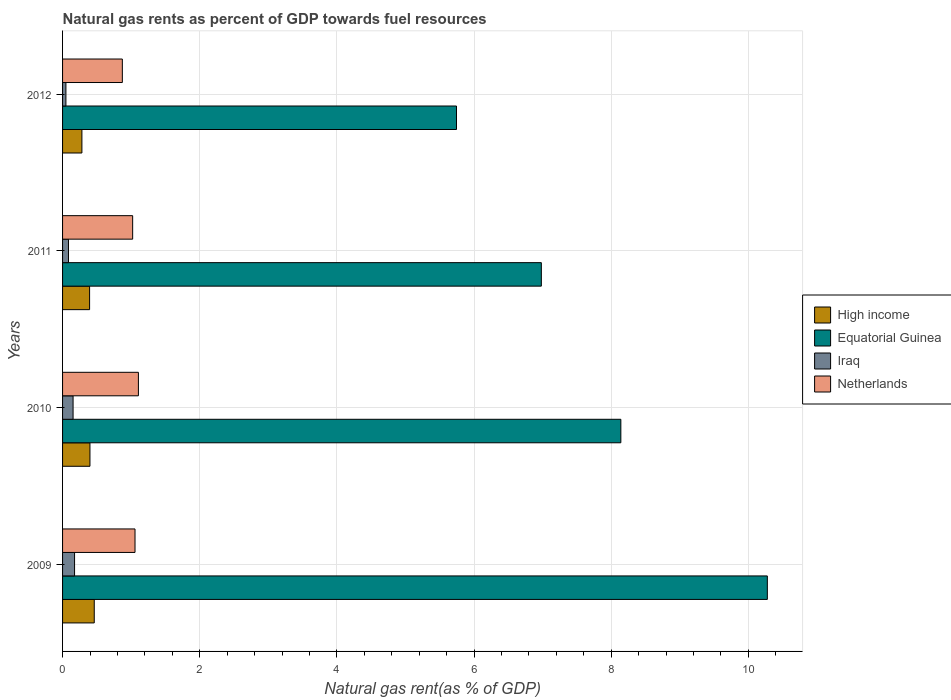How many different coloured bars are there?
Offer a terse response. 4. In how many cases, is the number of bars for a given year not equal to the number of legend labels?
Make the answer very short. 0. What is the natural gas rent in High income in 2010?
Your response must be concise. 0.4. Across all years, what is the maximum natural gas rent in Iraq?
Keep it short and to the point. 0.17. Across all years, what is the minimum natural gas rent in High income?
Offer a terse response. 0.28. In which year was the natural gas rent in Equatorial Guinea minimum?
Your answer should be compact. 2012. What is the total natural gas rent in Equatorial Guinea in the graph?
Offer a terse response. 31.14. What is the difference between the natural gas rent in High income in 2009 and that in 2010?
Your answer should be very brief. 0.06. What is the difference between the natural gas rent in Iraq in 2010 and the natural gas rent in Netherlands in 2011?
Provide a short and direct response. -0.87. What is the average natural gas rent in Equatorial Guinea per year?
Ensure brevity in your answer.  7.79. In the year 2011, what is the difference between the natural gas rent in Iraq and natural gas rent in High income?
Provide a succinct answer. -0.31. What is the ratio of the natural gas rent in Equatorial Guinea in 2009 to that in 2012?
Your answer should be compact. 1.79. Is the difference between the natural gas rent in Iraq in 2009 and 2010 greater than the difference between the natural gas rent in High income in 2009 and 2010?
Offer a very short reply. No. What is the difference between the highest and the second highest natural gas rent in Equatorial Guinea?
Your answer should be compact. 2.14. What is the difference between the highest and the lowest natural gas rent in Equatorial Guinea?
Offer a terse response. 4.53. In how many years, is the natural gas rent in Iraq greater than the average natural gas rent in Iraq taken over all years?
Provide a succinct answer. 2. Is the sum of the natural gas rent in Netherlands in 2010 and 2011 greater than the maximum natural gas rent in Iraq across all years?
Ensure brevity in your answer.  Yes. Is it the case that in every year, the sum of the natural gas rent in High income and natural gas rent in Netherlands is greater than the sum of natural gas rent in Equatorial Guinea and natural gas rent in Iraq?
Ensure brevity in your answer.  Yes. What does the 3rd bar from the top in 2009 represents?
Ensure brevity in your answer.  Equatorial Guinea. Are all the bars in the graph horizontal?
Ensure brevity in your answer.  Yes. Does the graph contain grids?
Provide a succinct answer. Yes. Where does the legend appear in the graph?
Give a very brief answer. Center right. How are the legend labels stacked?
Offer a very short reply. Vertical. What is the title of the graph?
Ensure brevity in your answer.  Natural gas rents as percent of GDP towards fuel resources. What is the label or title of the X-axis?
Keep it short and to the point. Natural gas rent(as % of GDP). What is the Natural gas rent(as % of GDP) of High income in 2009?
Your response must be concise. 0.46. What is the Natural gas rent(as % of GDP) of Equatorial Guinea in 2009?
Ensure brevity in your answer.  10.28. What is the Natural gas rent(as % of GDP) of Iraq in 2009?
Your response must be concise. 0.17. What is the Natural gas rent(as % of GDP) of Netherlands in 2009?
Keep it short and to the point. 1.06. What is the Natural gas rent(as % of GDP) of High income in 2010?
Your answer should be very brief. 0.4. What is the Natural gas rent(as % of GDP) of Equatorial Guinea in 2010?
Give a very brief answer. 8.14. What is the Natural gas rent(as % of GDP) in Iraq in 2010?
Give a very brief answer. 0.15. What is the Natural gas rent(as % of GDP) in Netherlands in 2010?
Ensure brevity in your answer.  1.11. What is the Natural gas rent(as % of GDP) in High income in 2011?
Ensure brevity in your answer.  0.39. What is the Natural gas rent(as % of GDP) of Equatorial Guinea in 2011?
Your answer should be very brief. 6.98. What is the Natural gas rent(as % of GDP) in Iraq in 2011?
Offer a very short reply. 0.09. What is the Natural gas rent(as % of GDP) in Netherlands in 2011?
Make the answer very short. 1.02. What is the Natural gas rent(as % of GDP) in High income in 2012?
Your response must be concise. 0.28. What is the Natural gas rent(as % of GDP) in Equatorial Guinea in 2012?
Your response must be concise. 5.74. What is the Natural gas rent(as % of GDP) of Iraq in 2012?
Offer a very short reply. 0.05. What is the Natural gas rent(as % of GDP) in Netherlands in 2012?
Make the answer very short. 0.87. Across all years, what is the maximum Natural gas rent(as % of GDP) of High income?
Make the answer very short. 0.46. Across all years, what is the maximum Natural gas rent(as % of GDP) of Equatorial Guinea?
Provide a short and direct response. 10.28. Across all years, what is the maximum Natural gas rent(as % of GDP) in Iraq?
Your response must be concise. 0.17. Across all years, what is the maximum Natural gas rent(as % of GDP) of Netherlands?
Your answer should be very brief. 1.11. Across all years, what is the minimum Natural gas rent(as % of GDP) of High income?
Offer a very short reply. 0.28. Across all years, what is the minimum Natural gas rent(as % of GDP) of Equatorial Guinea?
Ensure brevity in your answer.  5.74. Across all years, what is the minimum Natural gas rent(as % of GDP) of Iraq?
Your response must be concise. 0.05. Across all years, what is the minimum Natural gas rent(as % of GDP) of Netherlands?
Give a very brief answer. 0.87. What is the total Natural gas rent(as % of GDP) of High income in the graph?
Ensure brevity in your answer.  1.54. What is the total Natural gas rent(as % of GDP) in Equatorial Guinea in the graph?
Ensure brevity in your answer.  31.14. What is the total Natural gas rent(as % of GDP) of Iraq in the graph?
Ensure brevity in your answer.  0.46. What is the total Natural gas rent(as % of GDP) in Netherlands in the graph?
Offer a very short reply. 4.06. What is the difference between the Natural gas rent(as % of GDP) of High income in 2009 and that in 2010?
Offer a terse response. 0.06. What is the difference between the Natural gas rent(as % of GDP) in Equatorial Guinea in 2009 and that in 2010?
Your answer should be compact. 2.14. What is the difference between the Natural gas rent(as % of GDP) of Iraq in 2009 and that in 2010?
Give a very brief answer. 0.02. What is the difference between the Natural gas rent(as % of GDP) of Netherlands in 2009 and that in 2010?
Your answer should be compact. -0.05. What is the difference between the Natural gas rent(as % of GDP) in High income in 2009 and that in 2011?
Ensure brevity in your answer.  0.07. What is the difference between the Natural gas rent(as % of GDP) of Equatorial Guinea in 2009 and that in 2011?
Your answer should be compact. 3.3. What is the difference between the Natural gas rent(as % of GDP) in Iraq in 2009 and that in 2011?
Give a very brief answer. 0.09. What is the difference between the Natural gas rent(as % of GDP) of Netherlands in 2009 and that in 2011?
Give a very brief answer. 0.03. What is the difference between the Natural gas rent(as % of GDP) of High income in 2009 and that in 2012?
Provide a short and direct response. 0.18. What is the difference between the Natural gas rent(as % of GDP) in Equatorial Guinea in 2009 and that in 2012?
Keep it short and to the point. 4.53. What is the difference between the Natural gas rent(as % of GDP) of Iraq in 2009 and that in 2012?
Offer a terse response. 0.13. What is the difference between the Natural gas rent(as % of GDP) of Netherlands in 2009 and that in 2012?
Offer a very short reply. 0.18. What is the difference between the Natural gas rent(as % of GDP) in High income in 2010 and that in 2011?
Your answer should be compact. 0.01. What is the difference between the Natural gas rent(as % of GDP) of Equatorial Guinea in 2010 and that in 2011?
Make the answer very short. 1.16. What is the difference between the Natural gas rent(as % of GDP) in Iraq in 2010 and that in 2011?
Your answer should be very brief. 0.07. What is the difference between the Natural gas rent(as % of GDP) in Netherlands in 2010 and that in 2011?
Your answer should be compact. 0.08. What is the difference between the Natural gas rent(as % of GDP) in High income in 2010 and that in 2012?
Your answer should be compact. 0.12. What is the difference between the Natural gas rent(as % of GDP) of Equatorial Guinea in 2010 and that in 2012?
Provide a short and direct response. 2.4. What is the difference between the Natural gas rent(as % of GDP) of Iraq in 2010 and that in 2012?
Provide a succinct answer. 0.1. What is the difference between the Natural gas rent(as % of GDP) in Netherlands in 2010 and that in 2012?
Provide a succinct answer. 0.23. What is the difference between the Natural gas rent(as % of GDP) of High income in 2011 and that in 2012?
Provide a succinct answer. 0.11. What is the difference between the Natural gas rent(as % of GDP) in Equatorial Guinea in 2011 and that in 2012?
Give a very brief answer. 1.24. What is the difference between the Natural gas rent(as % of GDP) of Iraq in 2011 and that in 2012?
Your answer should be very brief. 0.04. What is the difference between the Natural gas rent(as % of GDP) in Netherlands in 2011 and that in 2012?
Provide a short and direct response. 0.15. What is the difference between the Natural gas rent(as % of GDP) in High income in 2009 and the Natural gas rent(as % of GDP) in Equatorial Guinea in 2010?
Your answer should be compact. -7.68. What is the difference between the Natural gas rent(as % of GDP) of High income in 2009 and the Natural gas rent(as % of GDP) of Iraq in 2010?
Make the answer very short. 0.31. What is the difference between the Natural gas rent(as % of GDP) in High income in 2009 and the Natural gas rent(as % of GDP) in Netherlands in 2010?
Offer a terse response. -0.64. What is the difference between the Natural gas rent(as % of GDP) in Equatorial Guinea in 2009 and the Natural gas rent(as % of GDP) in Iraq in 2010?
Offer a terse response. 10.12. What is the difference between the Natural gas rent(as % of GDP) in Equatorial Guinea in 2009 and the Natural gas rent(as % of GDP) in Netherlands in 2010?
Provide a succinct answer. 9.17. What is the difference between the Natural gas rent(as % of GDP) of Iraq in 2009 and the Natural gas rent(as % of GDP) of Netherlands in 2010?
Provide a succinct answer. -0.93. What is the difference between the Natural gas rent(as % of GDP) in High income in 2009 and the Natural gas rent(as % of GDP) in Equatorial Guinea in 2011?
Provide a succinct answer. -6.52. What is the difference between the Natural gas rent(as % of GDP) in High income in 2009 and the Natural gas rent(as % of GDP) in Iraq in 2011?
Your response must be concise. 0.38. What is the difference between the Natural gas rent(as % of GDP) of High income in 2009 and the Natural gas rent(as % of GDP) of Netherlands in 2011?
Your answer should be very brief. -0.56. What is the difference between the Natural gas rent(as % of GDP) of Equatorial Guinea in 2009 and the Natural gas rent(as % of GDP) of Iraq in 2011?
Provide a succinct answer. 10.19. What is the difference between the Natural gas rent(as % of GDP) of Equatorial Guinea in 2009 and the Natural gas rent(as % of GDP) of Netherlands in 2011?
Ensure brevity in your answer.  9.25. What is the difference between the Natural gas rent(as % of GDP) in Iraq in 2009 and the Natural gas rent(as % of GDP) in Netherlands in 2011?
Make the answer very short. -0.85. What is the difference between the Natural gas rent(as % of GDP) of High income in 2009 and the Natural gas rent(as % of GDP) of Equatorial Guinea in 2012?
Make the answer very short. -5.28. What is the difference between the Natural gas rent(as % of GDP) in High income in 2009 and the Natural gas rent(as % of GDP) in Iraq in 2012?
Ensure brevity in your answer.  0.41. What is the difference between the Natural gas rent(as % of GDP) in High income in 2009 and the Natural gas rent(as % of GDP) in Netherlands in 2012?
Keep it short and to the point. -0.41. What is the difference between the Natural gas rent(as % of GDP) of Equatorial Guinea in 2009 and the Natural gas rent(as % of GDP) of Iraq in 2012?
Keep it short and to the point. 10.23. What is the difference between the Natural gas rent(as % of GDP) of Equatorial Guinea in 2009 and the Natural gas rent(as % of GDP) of Netherlands in 2012?
Offer a terse response. 9.41. What is the difference between the Natural gas rent(as % of GDP) in Iraq in 2009 and the Natural gas rent(as % of GDP) in Netherlands in 2012?
Keep it short and to the point. -0.7. What is the difference between the Natural gas rent(as % of GDP) of High income in 2010 and the Natural gas rent(as % of GDP) of Equatorial Guinea in 2011?
Keep it short and to the point. -6.58. What is the difference between the Natural gas rent(as % of GDP) of High income in 2010 and the Natural gas rent(as % of GDP) of Iraq in 2011?
Provide a succinct answer. 0.31. What is the difference between the Natural gas rent(as % of GDP) in High income in 2010 and the Natural gas rent(as % of GDP) in Netherlands in 2011?
Your answer should be very brief. -0.62. What is the difference between the Natural gas rent(as % of GDP) in Equatorial Guinea in 2010 and the Natural gas rent(as % of GDP) in Iraq in 2011?
Ensure brevity in your answer.  8.05. What is the difference between the Natural gas rent(as % of GDP) of Equatorial Guinea in 2010 and the Natural gas rent(as % of GDP) of Netherlands in 2011?
Ensure brevity in your answer.  7.12. What is the difference between the Natural gas rent(as % of GDP) of Iraq in 2010 and the Natural gas rent(as % of GDP) of Netherlands in 2011?
Your answer should be compact. -0.87. What is the difference between the Natural gas rent(as % of GDP) in High income in 2010 and the Natural gas rent(as % of GDP) in Equatorial Guinea in 2012?
Keep it short and to the point. -5.34. What is the difference between the Natural gas rent(as % of GDP) in High income in 2010 and the Natural gas rent(as % of GDP) in Iraq in 2012?
Provide a succinct answer. 0.35. What is the difference between the Natural gas rent(as % of GDP) in High income in 2010 and the Natural gas rent(as % of GDP) in Netherlands in 2012?
Your response must be concise. -0.47. What is the difference between the Natural gas rent(as % of GDP) in Equatorial Guinea in 2010 and the Natural gas rent(as % of GDP) in Iraq in 2012?
Your answer should be very brief. 8.09. What is the difference between the Natural gas rent(as % of GDP) in Equatorial Guinea in 2010 and the Natural gas rent(as % of GDP) in Netherlands in 2012?
Keep it short and to the point. 7.27. What is the difference between the Natural gas rent(as % of GDP) of Iraq in 2010 and the Natural gas rent(as % of GDP) of Netherlands in 2012?
Your answer should be compact. -0.72. What is the difference between the Natural gas rent(as % of GDP) of High income in 2011 and the Natural gas rent(as % of GDP) of Equatorial Guinea in 2012?
Give a very brief answer. -5.35. What is the difference between the Natural gas rent(as % of GDP) of High income in 2011 and the Natural gas rent(as % of GDP) of Iraq in 2012?
Ensure brevity in your answer.  0.35. What is the difference between the Natural gas rent(as % of GDP) of High income in 2011 and the Natural gas rent(as % of GDP) of Netherlands in 2012?
Your response must be concise. -0.48. What is the difference between the Natural gas rent(as % of GDP) in Equatorial Guinea in 2011 and the Natural gas rent(as % of GDP) in Iraq in 2012?
Offer a terse response. 6.93. What is the difference between the Natural gas rent(as % of GDP) in Equatorial Guinea in 2011 and the Natural gas rent(as % of GDP) in Netherlands in 2012?
Provide a succinct answer. 6.11. What is the difference between the Natural gas rent(as % of GDP) of Iraq in 2011 and the Natural gas rent(as % of GDP) of Netherlands in 2012?
Make the answer very short. -0.79. What is the average Natural gas rent(as % of GDP) of High income per year?
Your response must be concise. 0.38. What is the average Natural gas rent(as % of GDP) of Equatorial Guinea per year?
Keep it short and to the point. 7.79. What is the average Natural gas rent(as % of GDP) of Iraq per year?
Your response must be concise. 0.12. What is the average Natural gas rent(as % of GDP) of Netherlands per year?
Keep it short and to the point. 1.01. In the year 2009, what is the difference between the Natural gas rent(as % of GDP) in High income and Natural gas rent(as % of GDP) in Equatorial Guinea?
Offer a very short reply. -9.81. In the year 2009, what is the difference between the Natural gas rent(as % of GDP) in High income and Natural gas rent(as % of GDP) in Iraq?
Your answer should be very brief. 0.29. In the year 2009, what is the difference between the Natural gas rent(as % of GDP) in High income and Natural gas rent(as % of GDP) in Netherlands?
Ensure brevity in your answer.  -0.59. In the year 2009, what is the difference between the Natural gas rent(as % of GDP) of Equatorial Guinea and Natural gas rent(as % of GDP) of Iraq?
Make the answer very short. 10.1. In the year 2009, what is the difference between the Natural gas rent(as % of GDP) in Equatorial Guinea and Natural gas rent(as % of GDP) in Netherlands?
Offer a terse response. 9.22. In the year 2009, what is the difference between the Natural gas rent(as % of GDP) of Iraq and Natural gas rent(as % of GDP) of Netherlands?
Your answer should be compact. -0.88. In the year 2010, what is the difference between the Natural gas rent(as % of GDP) of High income and Natural gas rent(as % of GDP) of Equatorial Guinea?
Keep it short and to the point. -7.74. In the year 2010, what is the difference between the Natural gas rent(as % of GDP) in High income and Natural gas rent(as % of GDP) in Iraq?
Provide a succinct answer. 0.25. In the year 2010, what is the difference between the Natural gas rent(as % of GDP) of High income and Natural gas rent(as % of GDP) of Netherlands?
Your answer should be compact. -0.71. In the year 2010, what is the difference between the Natural gas rent(as % of GDP) of Equatorial Guinea and Natural gas rent(as % of GDP) of Iraq?
Offer a terse response. 7.99. In the year 2010, what is the difference between the Natural gas rent(as % of GDP) of Equatorial Guinea and Natural gas rent(as % of GDP) of Netherlands?
Offer a very short reply. 7.03. In the year 2010, what is the difference between the Natural gas rent(as % of GDP) in Iraq and Natural gas rent(as % of GDP) in Netherlands?
Offer a terse response. -0.95. In the year 2011, what is the difference between the Natural gas rent(as % of GDP) of High income and Natural gas rent(as % of GDP) of Equatorial Guinea?
Offer a terse response. -6.59. In the year 2011, what is the difference between the Natural gas rent(as % of GDP) of High income and Natural gas rent(as % of GDP) of Iraq?
Make the answer very short. 0.31. In the year 2011, what is the difference between the Natural gas rent(as % of GDP) of High income and Natural gas rent(as % of GDP) of Netherlands?
Your response must be concise. -0.63. In the year 2011, what is the difference between the Natural gas rent(as % of GDP) of Equatorial Guinea and Natural gas rent(as % of GDP) of Iraq?
Keep it short and to the point. 6.9. In the year 2011, what is the difference between the Natural gas rent(as % of GDP) of Equatorial Guinea and Natural gas rent(as % of GDP) of Netherlands?
Ensure brevity in your answer.  5.96. In the year 2011, what is the difference between the Natural gas rent(as % of GDP) of Iraq and Natural gas rent(as % of GDP) of Netherlands?
Keep it short and to the point. -0.94. In the year 2012, what is the difference between the Natural gas rent(as % of GDP) in High income and Natural gas rent(as % of GDP) in Equatorial Guinea?
Your response must be concise. -5.46. In the year 2012, what is the difference between the Natural gas rent(as % of GDP) of High income and Natural gas rent(as % of GDP) of Iraq?
Provide a succinct answer. 0.23. In the year 2012, what is the difference between the Natural gas rent(as % of GDP) in High income and Natural gas rent(as % of GDP) in Netherlands?
Give a very brief answer. -0.59. In the year 2012, what is the difference between the Natural gas rent(as % of GDP) of Equatorial Guinea and Natural gas rent(as % of GDP) of Iraq?
Offer a very short reply. 5.7. In the year 2012, what is the difference between the Natural gas rent(as % of GDP) of Equatorial Guinea and Natural gas rent(as % of GDP) of Netherlands?
Ensure brevity in your answer.  4.87. In the year 2012, what is the difference between the Natural gas rent(as % of GDP) in Iraq and Natural gas rent(as % of GDP) in Netherlands?
Provide a succinct answer. -0.82. What is the ratio of the Natural gas rent(as % of GDP) of High income in 2009 to that in 2010?
Provide a succinct answer. 1.16. What is the ratio of the Natural gas rent(as % of GDP) of Equatorial Guinea in 2009 to that in 2010?
Provide a short and direct response. 1.26. What is the ratio of the Natural gas rent(as % of GDP) of Iraq in 2009 to that in 2010?
Provide a short and direct response. 1.14. What is the ratio of the Natural gas rent(as % of GDP) of Netherlands in 2009 to that in 2010?
Give a very brief answer. 0.96. What is the ratio of the Natural gas rent(as % of GDP) of High income in 2009 to that in 2011?
Offer a very short reply. 1.17. What is the ratio of the Natural gas rent(as % of GDP) in Equatorial Guinea in 2009 to that in 2011?
Provide a succinct answer. 1.47. What is the ratio of the Natural gas rent(as % of GDP) in Iraq in 2009 to that in 2011?
Provide a succinct answer. 2.02. What is the ratio of the Natural gas rent(as % of GDP) of Netherlands in 2009 to that in 2011?
Ensure brevity in your answer.  1.03. What is the ratio of the Natural gas rent(as % of GDP) in High income in 2009 to that in 2012?
Your response must be concise. 1.64. What is the ratio of the Natural gas rent(as % of GDP) in Equatorial Guinea in 2009 to that in 2012?
Make the answer very short. 1.79. What is the ratio of the Natural gas rent(as % of GDP) in Iraq in 2009 to that in 2012?
Offer a very short reply. 3.57. What is the ratio of the Natural gas rent(as % of GDP) in Netherlands in 2009 to that in 2012?
Your answer should be compact. 1.21. What is the ratio of the Natural gas rent(as % of GDP) of High income in 2010 to that in 2011?
Give a very brief answer. 1.01. What is the ratio of the Natural gas rent(as % of GDP) of Equatorial Guinea in 2010 to that in 2011?
Offer a very short reply. 1.17. What is the ratio of the Natural gas rent(as % of GDP) of Iraq in 2010 to that in 2011?
Your response must be concise. 1.77. What is the ratio of the Natural gas rent(as % of GDP) in Netherlands in 2010 to that in 2011?
Offer a very short reply. 1.08. What is the ratio of the Natural gas rent(as % of GDP) of High income in 2010 to that in 2012?
Give a very brief answer. 1.42. What is the ratio of the Natural gas rent(as % of GDP) in Equatorial Guinea in 2010 to that in 2012?
Ensure brevity in your answer.  1.42. What is the ratio of the Natural gas rent(as % of GDP) of Iraq in 2010 to that in 2012?
Your response must be concise. 3.13. What is the ratio of the Natural gas rent(as % of GDP) in Netherlands in 2010 to that in 2012?
Keep it short and to the point. 1.27. What is the ratio of the Natural gas rent(as % of GDP) in High income in 2011 to that in 2012?
Offer a terse response. 1.4. What is the ratio of the Natural gas rent(as % of GDP) in Equatorial Guinea in 2011 to that in 2012?
Keep it short and to the point. 1.22. What is the ratio of the Natural gas rent(as % of GDP) of Iraq in 2011 to that in 2012?
Make the answer very short. 1.76. What is the ratio of the Natural gas rent(as % of GDP) in Netherlands in 2011 to that in 2012?
Provide a succinct answer. 1.17. What is the difference between the highest and the second highest Natural gas rent(as % of GDP) of High income?
Offer a terse response. 0.06. What is the difference between the highest and the second highest Natural gas rent(as % of GDP) of Equatorial Guinea?
Ensure brevity in your answer.  2.14. What is the difference between the highest and the second highest Natural gas rent(as % of GDP) in Iraq?
Your response must be concise. 0.02. What is the difference between the highest and the second highest Natural gas rent(as % of GDP) in Netherlands?
Give a very brief answer. 0.05. What is the difference between the highest and the lowest Natural gas rent(as % of GDP) of High income?
Make the answer very short. 0.18. What is the difference between the highest and the lowest Natural gas rent(as % of GDP) of Equatorial Guinea?
Give a very brief answer. 4.53. What is the difference between the highest and the lowest Natural gas rent(as % of GDP) in Iraq?
Your response must be concise. 0.13. What is the difference between the highest and the lowest Natural gas rent(as % of GDP) of Netherlands?
Offer a very short reply. 0.23. 